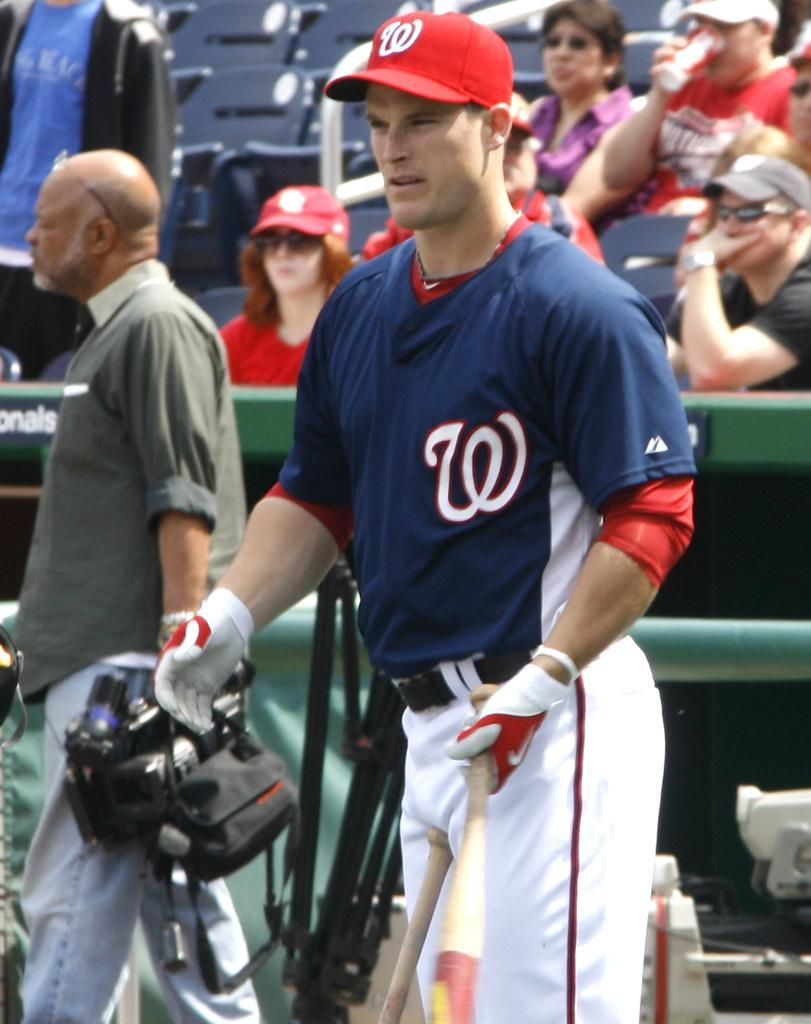In one or two sentences, can you explain what this image depicts? In the picture I can see people among them two men in the front are holding some objects in hands. In the background I can see chairs. The background of the image is blurred. 